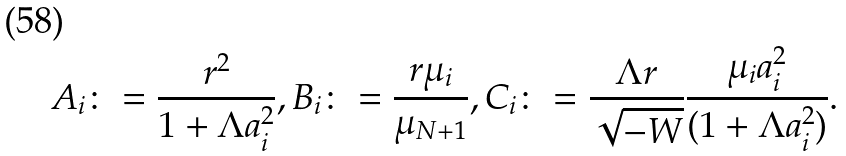Convert formula to latex. <formula><loc_0><loc_0><loc_500><loc_500>A _ { i } \colon = \frac { r ^ { 2 } } { 1 + \Lambda a _ { i } ^ { 2 } } , B _ { i } \colon = \frac { r \mu _ { i } } { \mu _ { N + 1 } } , C _ { i } \colon = \frac { \Lambda r } { \sqrt { - W } } \frac { \mu _ { i } a _ { i } ^ { 2 } } { ( 1 + \Lambda a _ { i } ^ { 2 } ) } .</formula> 